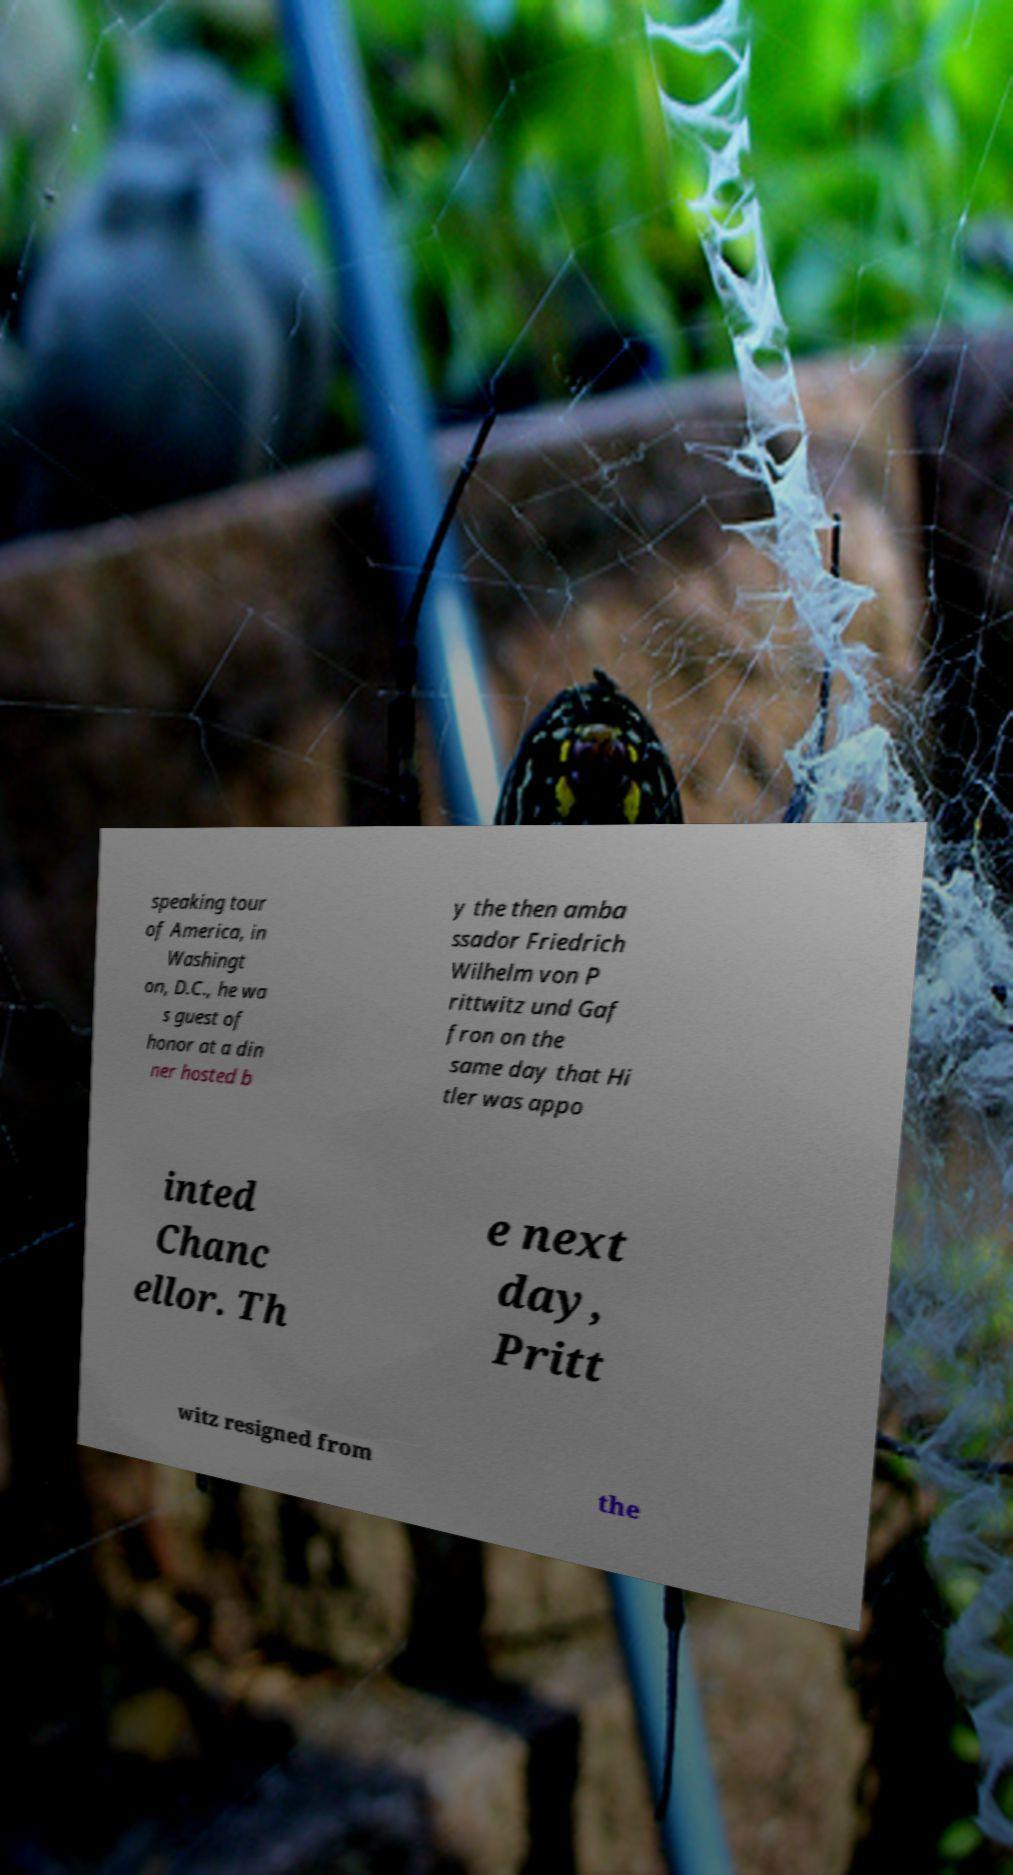Can you read and provide the text displayed in the image?This photo seems to have some interesting text. Can you extract and type it out for me? speaking tour of America, in Washingt on, D.C., he wa s guest of honor at a din ner hosted b y the then amba ssador Friedrich Wilhelm von P rittwitz und Gaf fron on the same day that Hi tler was appo inted Chanc ellor. Th e next day, Pritt witz resigned from the 